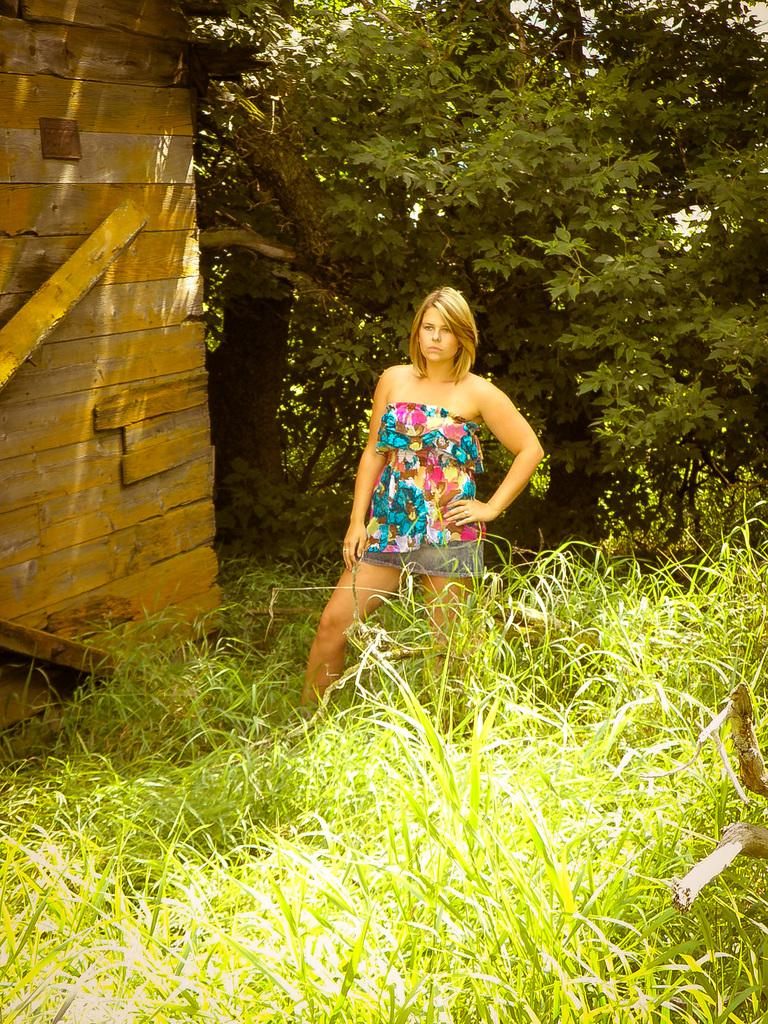What is the main subject of the image? The main subject of the image is a woman standing. What is the woman standing on? The woman is standing on the ground. What type of vegetation can be seen in the image? There is grass visible in the image. What is the background of the image? There is a wall in the image, and trees can be seen in the background. What is the woman's tendency to eat lunch in the image? There is no information about the woman's lunch habits in the image. What is the woman's interest in the image? There is no information about the woman's interests in the image. 